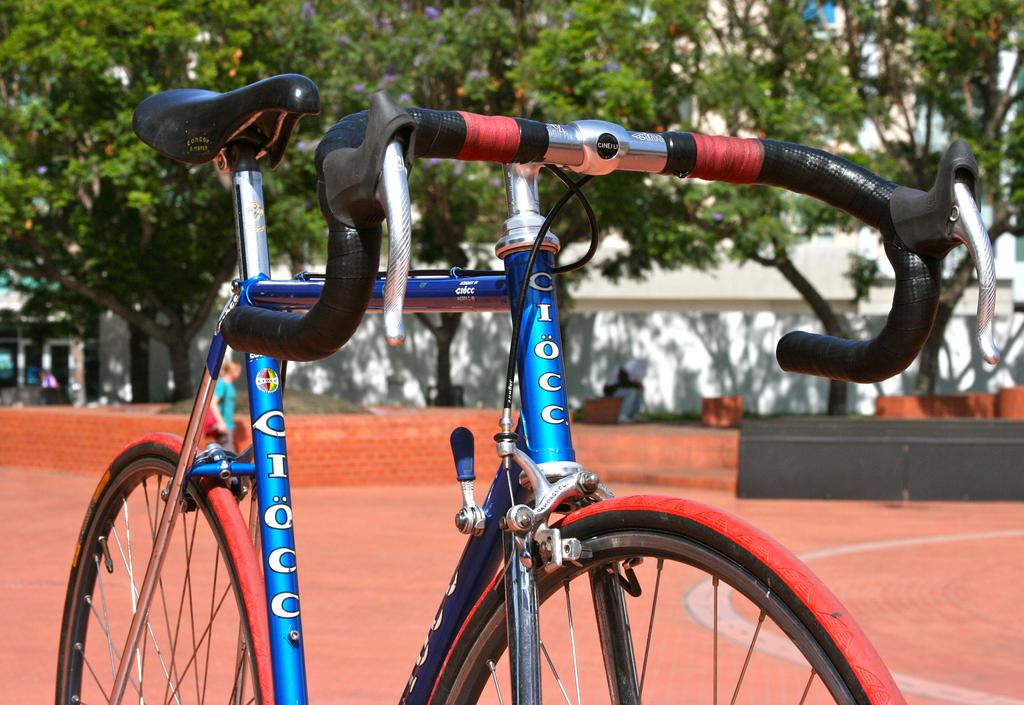What object is on the ground in the image? There is a bicycle on the ground in the image. What can be seen in the background of the image? Walls and trees are visible in the background of the image. How many spiders are crawling on the bicycle in the image? There are no spiders visible on the bicycle in the image. 